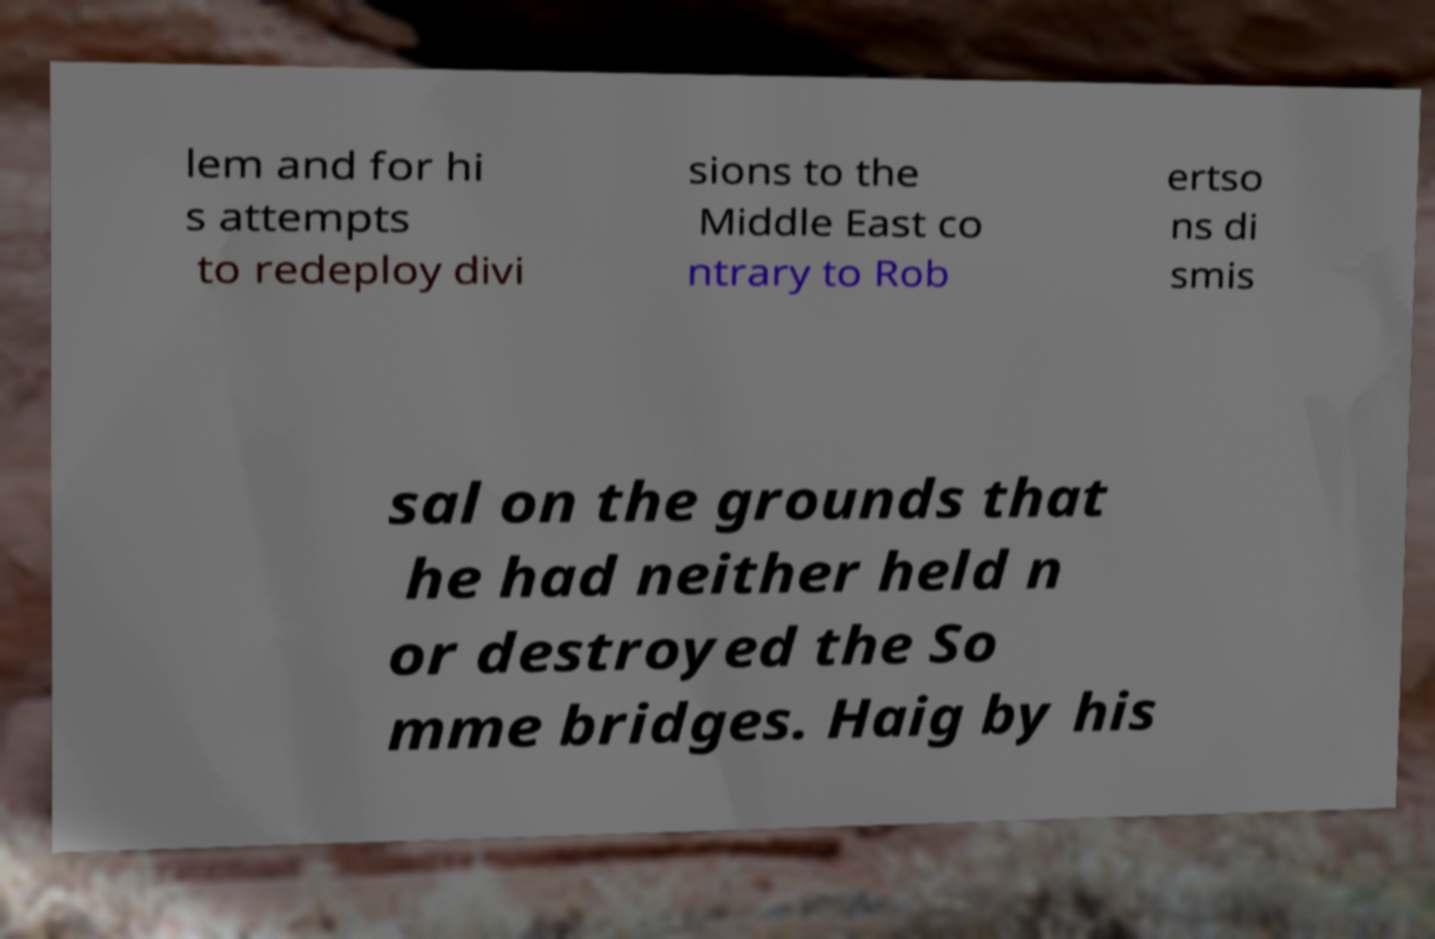Could you assist in decoding the text presented in this image and type it out clearly? lem and for hi s attempts to redeploy divi sions to the Middle East co ntrary to Rob ertso ns di smis sal on the grounds that he had neither held n or destroyed the So mme bridges. Haig by his 